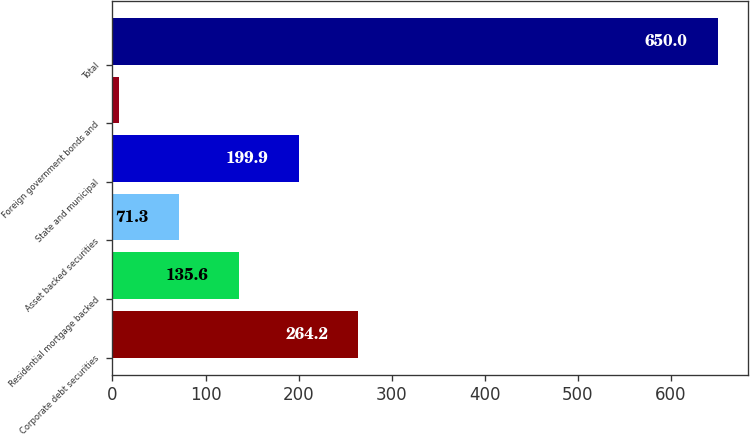Convert chart. <chart><loc_0><loc_0><loc_500><loc_500><bar_chart><fcel>Corporate debt securities<fcel>Residential mortgage backed<fcel>Asset backed securities<fcel>State and municipal<fcel>Foreign government bonds and<fcel>Total<nl><fcel>264.2<fcel>135.6<fcel>71.3<fcel>199.9<fcel>7<fcel>650<nl></chart> 